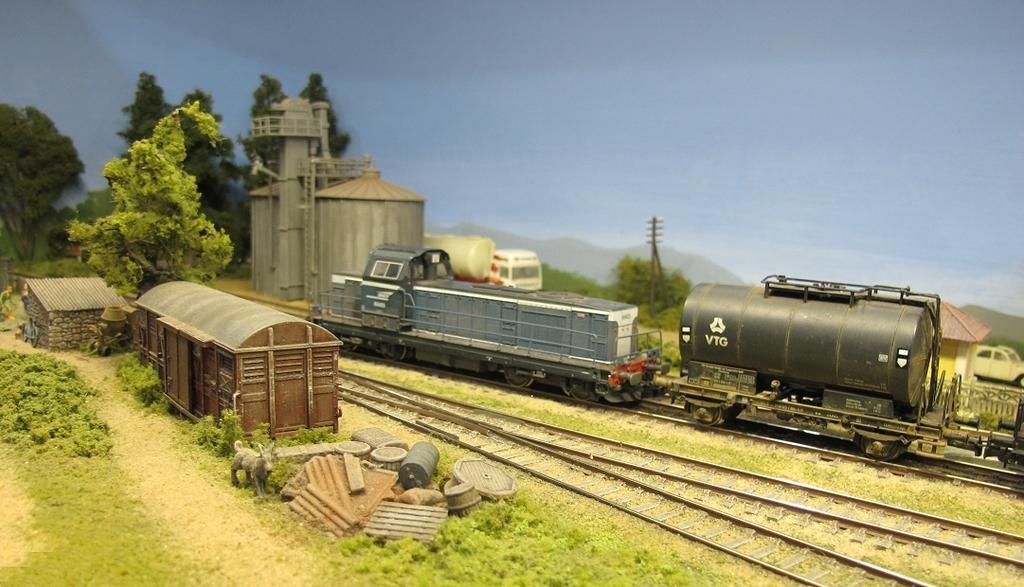What is the main subject of the image? The main subject of the image is a train. What is the train situated on? The train is situated on a railway track. What type of vegetation can be seen in the image? There is grass and trees visible in the image. What is present at the bottom of the image? There is a pole at the bottom of the image. What can be seen in the background of the image? The sky is visible in the background of the image. Where is the stove located in the image? There is no stove present in the image. What type of test is being conducted on the train in the image? There is no test being conducted on the train in the image. 